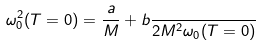Convert formula to latex. <formula><loc_0><loc_0><loc_500><loc_500>\omega _ { 0 } ^ { 2 } ( T = 0 ) = \frac { a } { M } + b \frac { } { 2 M ^ { 2 } \omega _ { 0 } ( T = 0 ) }</formula> 